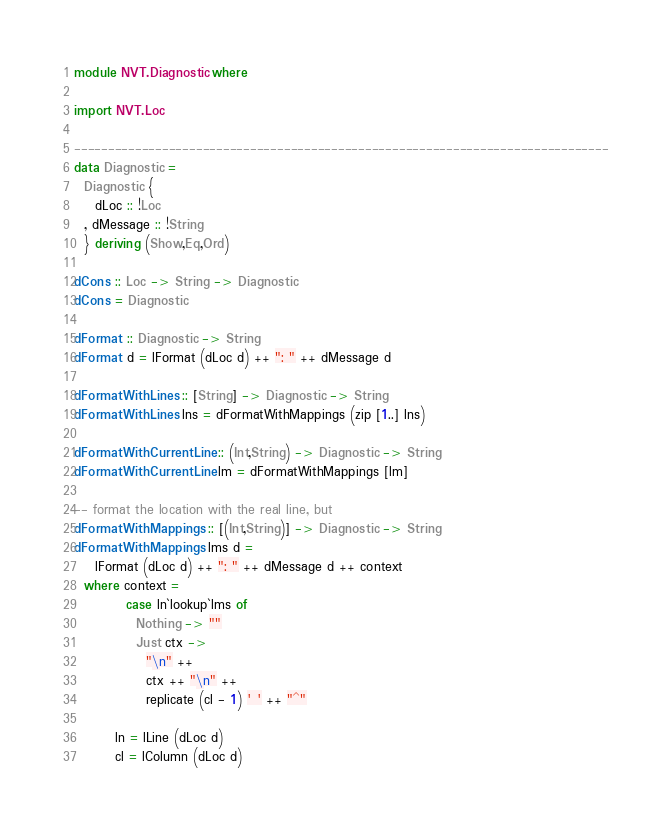Convert code to text. <code><loc_0><loc_0><loc_500><loc_500><_Haskell_>module NVT.Diagnostic where

import NVT.Loc

-------------------------------------------------------------------------------
data Diagnostic =
  Diagnostic {
    dLoc :: !Loc
  , dMessage :: !String
  } deriving (Show,Eq,Ord)

dCons :: Loc -> String -> Diagnostic
dCons = Diagnostic

dFormat :: Diagnostic -> String
dFormat d = lFormat (dLoc d) ++ ": " ++ dMessage d

dFormatWithLines :: [String] -> Diagnostic -> String
dFormatWithLines lns = dFormatWithMappings (zip [1..] lns)

dFormatWithCurrentLine :: (Int,String) -> Diagnostic -> String
dFormatWithCurrentLine lm = dFormatWithMappings [lm]

-- format the location with the real line, but
dFormatWithMappings :: [(Int,String)] -> Diagnostic -> String
dFormatWithMappings lms d =
    lFormat (dLoc d) ++ ": " ++ dMessage d ++ context
  where context =
          case ln`lookup`lms of
            Nothing -> ""
            Just ctx ->
              "\n" ++
              ctx ++ "\n" ++
              replicate (cl - 1) ' ' ++ "^"

        ln = lLine (dLoc d)
        cl = lColumn (dLoc d)
</code> 